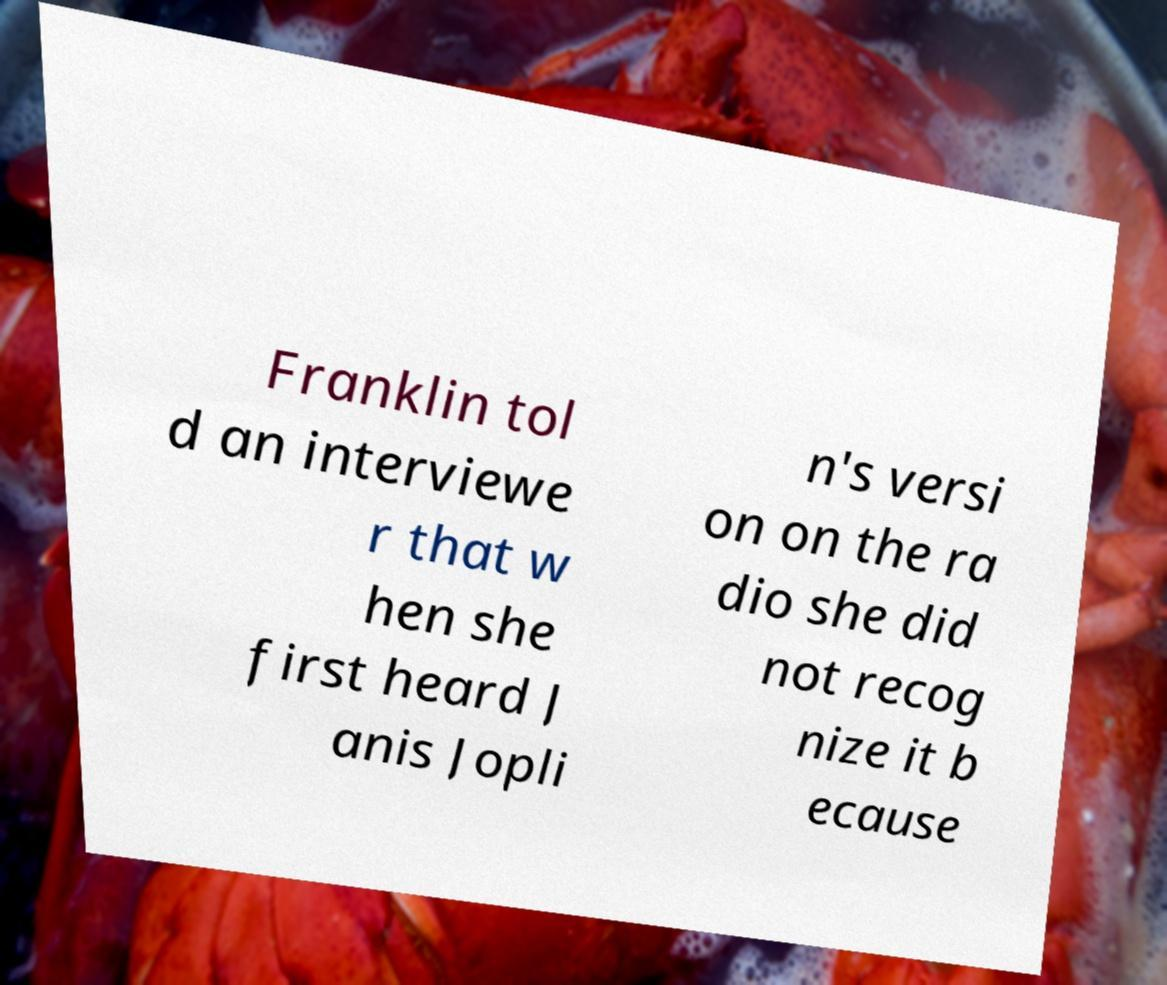Can you read and provide the text displayed in the image?This photo seems to have some interesting text. Can you extract and type it out for me? Franklin tol d an interviewe r that w hen she first heard J anis Jopli n's versi on on the ra dio she did not recog nize it b ecause 